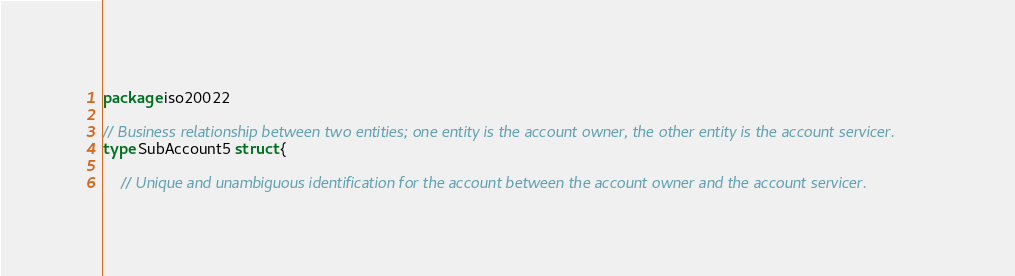<code> <loc_0><loc_0><loc_500><loc_500><_Go_>package iso20022

// Business relationship between two entities; one entity is the account owner, the other entity is the account servicer.
type SubAccount5 struct {

	// Unique and unambiguous identification for the account between the account owner and the account servicer.</code> 